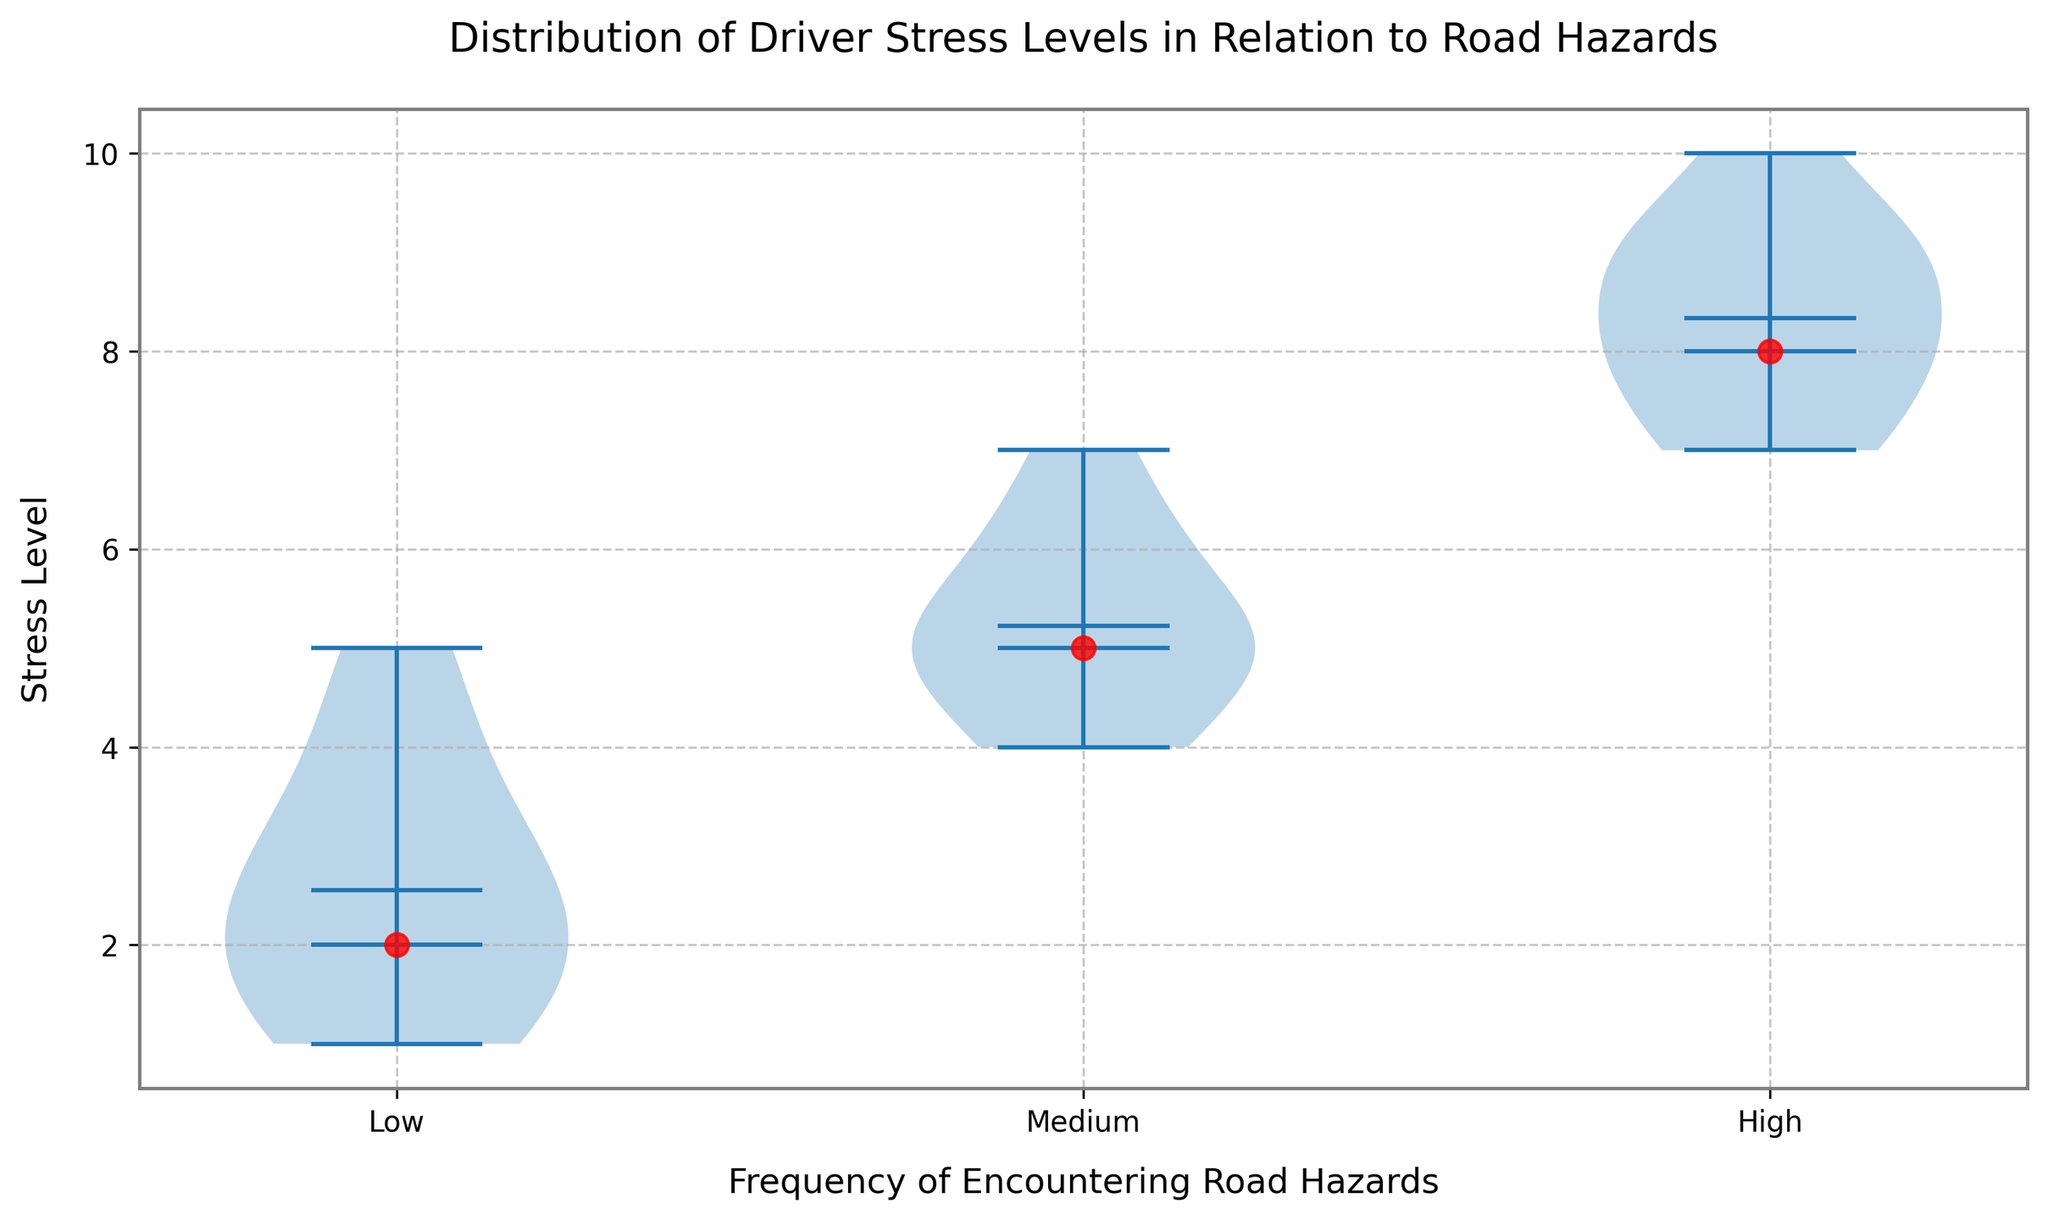What's the median stress level for drivers encountering a low frequency of road hazards? The median is found by arranging the stress levels for the "Low" category in ascending order: 1, 1, 2, 2, 2, 3, 3, 3, 4, 5. The middle value (median) in this sequence is 2.5.
Answer: 2.5 Which frequency category has the highest median stress level? From the data points plotted, the "High" frequency category has the highest median stress level.
Answer: High Is the range of stress levels higher for low or medium frequency of road hazards? The range is calculated by subtracting the minimum value from the maximum value. For "Low" frequency, the range is 5 - 1 = 4. For "Medium" frequency, the range is 7 - 4 = 3. Thus, the range is higher for "Low" frequency.
Answer: Low Which category shows the greatest spread in stress levels? The spread is visually noticeable by observing the width of the violins. The "High" frequency category shows the greatest spread as it spans from stress levels 7 to 10.
Answer: High Are the mean and median stress levels the same for the high frequency category? The medians are shown as red dots and the means are indicated by another marker. For the "High" frequency, the mean is slightly higher than the median.
Answer: No Which frequency category appears to have a bimodal distribution of stress levels? Observing the shape of the violins, the "Medium" frequency category appears to have two peaks, suggesting a bimodal distribution.
Answer: Medium Do any categories appear to have outliers in stress levels? None of the violin plots display obvious single points separated from the main body of data, indicating there are no prominent outliers.
Answer: No Is the mean stress level higher for medium or high frequency of road hazards? The mean stress levels are visually represented by the vertical line or marker in the violin plot. The "High" frequency category shows a higher mean stress level compared to "Medium".
Answer: High Is the interquartile range (IQR) greater for low or high frequency of road hazards? The IQR is visually represented by the width of the violin plot's bulk. The "High" frequency violin plot spreads wider than the "Low" frequency, indicating a larger IQR.
Answer: High 